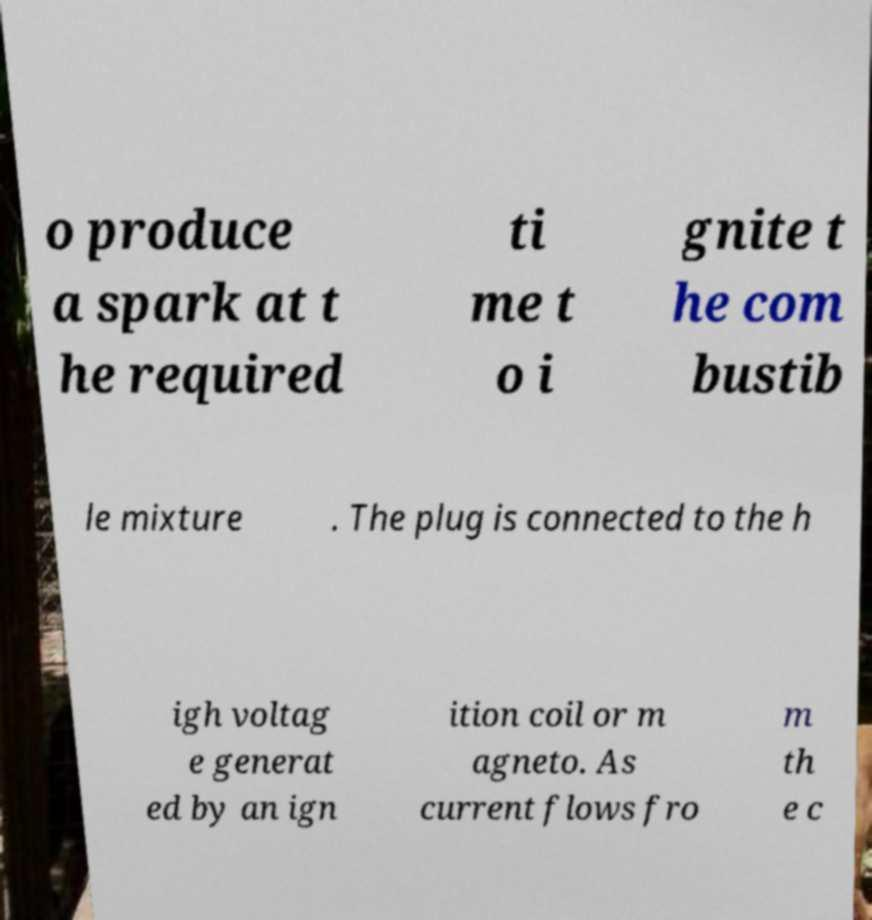Could you assist in decoding the text presented in this image and type it out clearly? o produce a spark at t he required ti me t o i gnite t he com bustib le mixture . The plug is connected to the h igh voltag e generat ed by an ign ition coil or m agneto. As current flows fro m th e c 